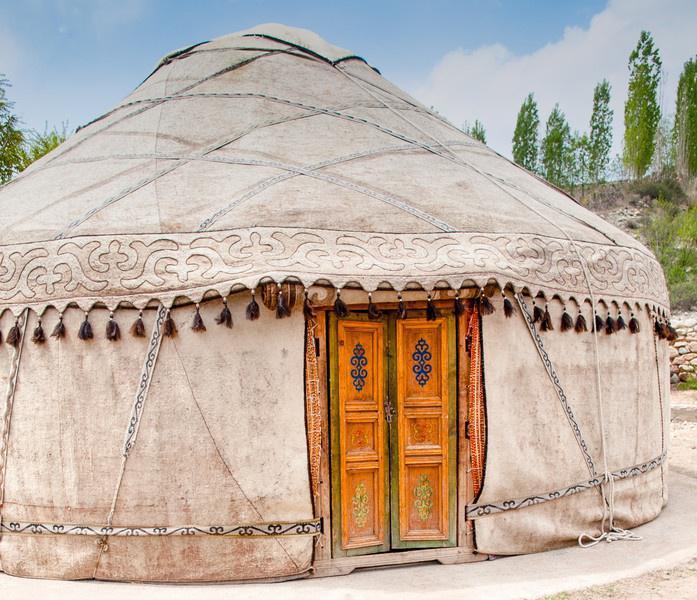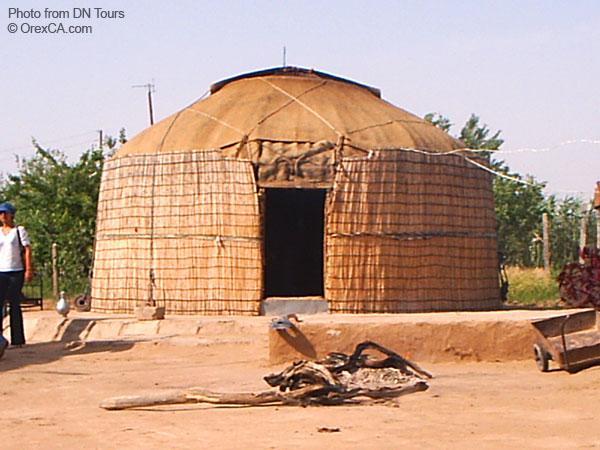The first image is the image on the left, the second image is the image on the right. Considering the images on both sides, is "There are 4 or more people next to tents." valid? Answer yes or no. No. The first image is the image on the left, the second image is the image on the right. Assess this claim about the two images: "The building has a wooden ornamental door". Correct or not? Answer yes or no. Yes. 